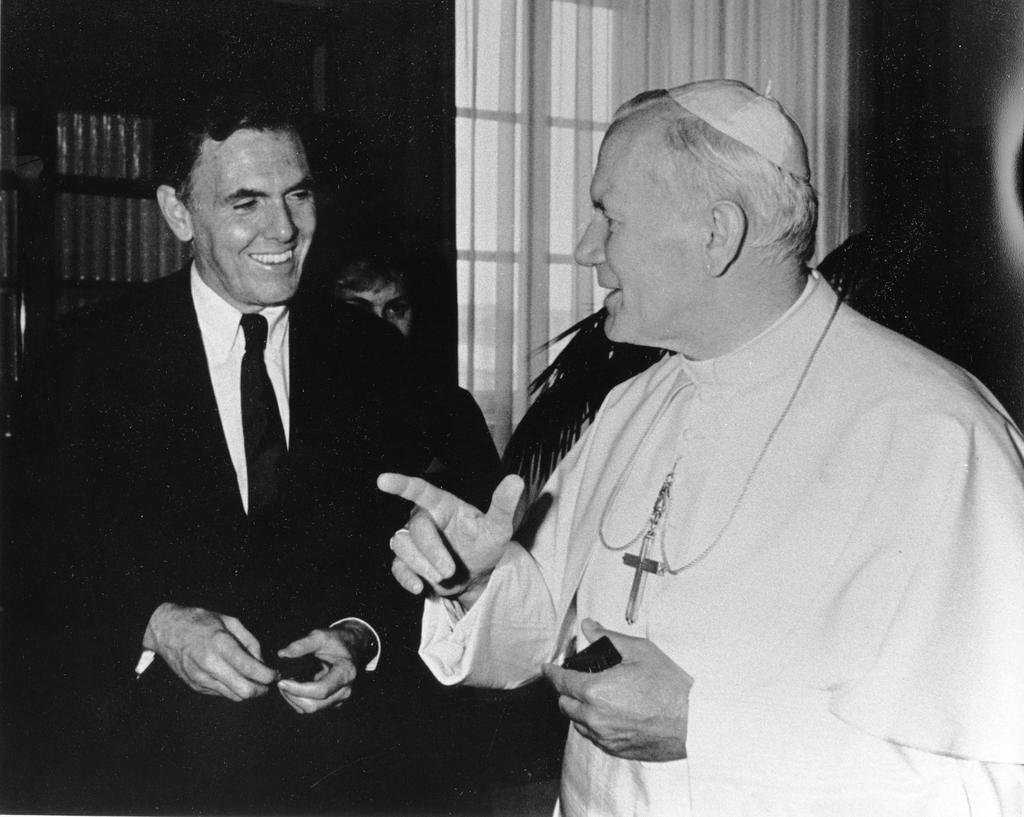How many people are in the image? There are two men in the image. What expressions do the men have? Both men are smiling. What can be seen in the background of the image? There is a curtain, a person, and a plant in the background of the image. What type of bike is the person riding in the image? There is no bike present in the image; it only features two men and background elements. What stamp can be seen on the plant in the image? There is no stamp on the plant in the image; it is simply a plant in the background. 